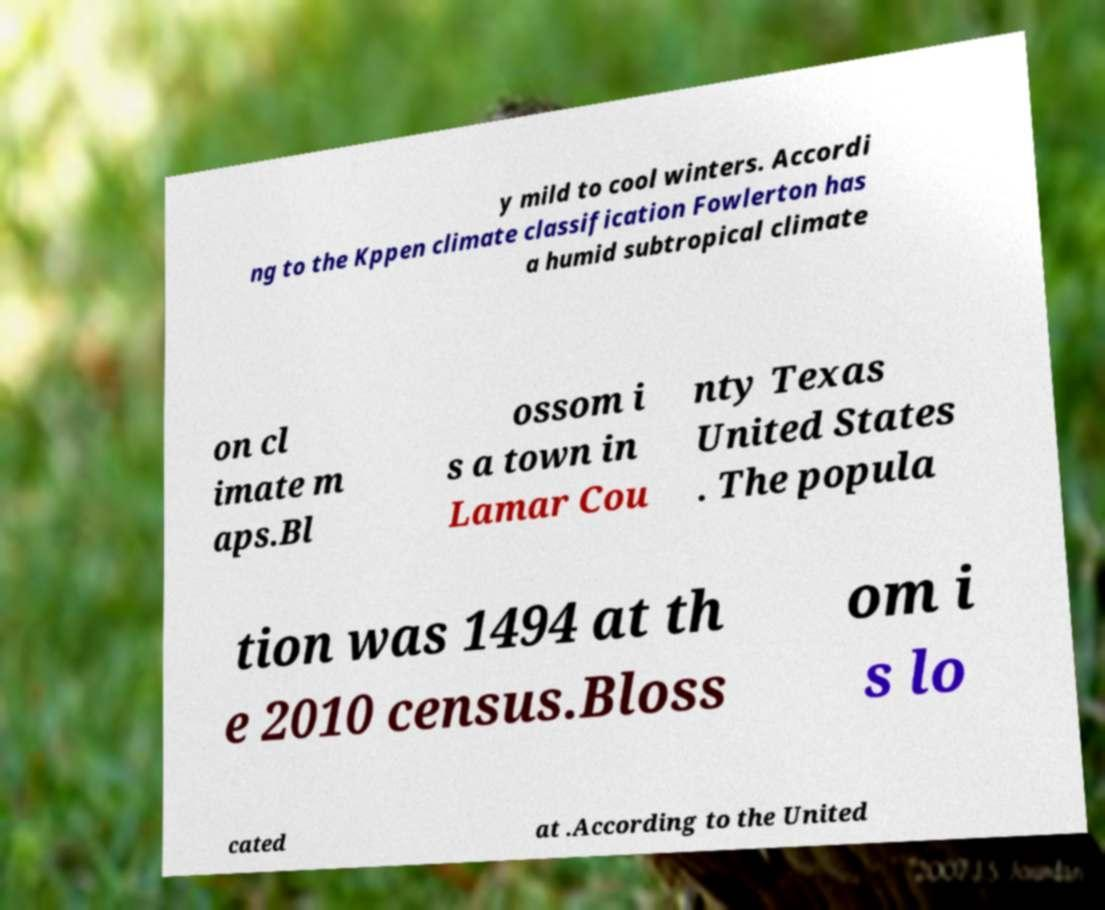Can you read and provide the text displayed in the image?This photo seems to have some interesting text. Can you extract and type it out for me? y mild to cool winters. Accordi ng to the Kppen climate classification Fowlerton has a humid subtropical climate on cl imate m aps.Bl ossom i s a town in Lamar Cou nty Texas United States . The popula tion was 1494 at th e 2010 census.Bloss om i s lo cated at .According to the United 